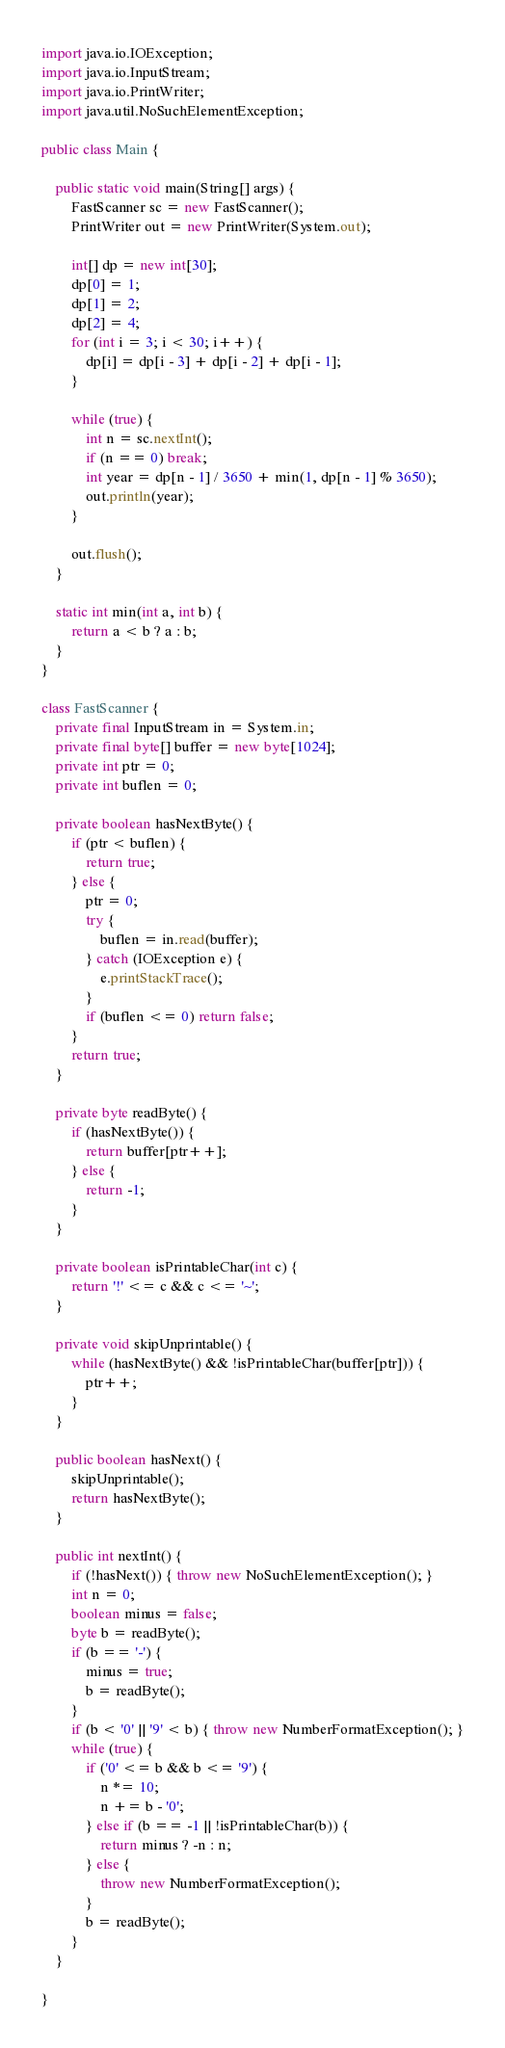Convert code to text. <code><loc_0><loc_0><loc_500><loc_500><_Java_>import java.io.IOException;
import java.io.InputStream;
import java.io.PrintWriter;
import java.util.NoSuchElementException;

public class Main {
	
	public static void main(String[] args) {
		FastScanner sc = new FastScanner();
		PrintWriter out = new PrintWriter(System.out);
		
		int[] dp = new int[30];
		dp[0] = 1;
		dp[1] = 2;
		dp[2] = 4;
		for (int i = 3; i < 30; i++) {
			dp[i] = dp[i - 3] + dp[i - 2] + dp[i - 1];
		}
		
		while (true) {
			int n = sc.nextInt();
			if (n == 0) break;
			int year = dp[n - 1] / 3650 + min(1, dp[n - 1] % 3650);
			out.println(year);
		}
		
		out.flush();
	}
	
	static int min(int a, int b) {
		return a < b ? a : b;
	}
}

class FastScanner {
	private final InputStream in = System.in;
	private final byte[] buffer = new byte[1024];
	private int ptr = 0;
	private int buflen = 0;
	
	private boolean hasNextByte() {
		if (ptr < buflen) {
			return true;
		} else {
			ptr = 0;
			try {
				buflen = in.read(buffer);
			} catch (IOException e) {
				e.printStackTrace();
			}
			if (buflen <= 0) return false;
		}
		return true;
	}
	
	private byte readByte() {
		if (hasNextByte()) {
			return buffer[ptr++];
		} else {
			return -1;
		}
	}
	
	private boolean isPrintableChar(int c) {
		return '!' <= c && c <= '~';
	}
	
	private void skipUnprintable() {
		while (hasNextByte() && !isPrintableChar(buffer[ptr])) {
			ptr++;
		}
	}
	
	public boolean hasNext() {
		skipUnprintable();
		return hasNextByte();
	}
	
	public int nextInt() {
		if (!hasNext()) { throw new NoSuchElementException(); }
		int n = 0;
		boolean minus = false;
		byte b = readByte();
		if (b == '-') {
			minus = true;
			b = readByte();
		}
		if (b < '0' || '9' < b) { throw new NumberFormatException(); }
		while (true) {
			if ('0' <= b && b <= '9') {
				n *= 10;
				n += b - '0';
			} else if (b == -1 || !isPrintableChar(b)) {
				return minus ? -n : n;
			} else {
				throw new NumberFormatException();
			}
			b = readByte();
		}
	}
	
}</code> 